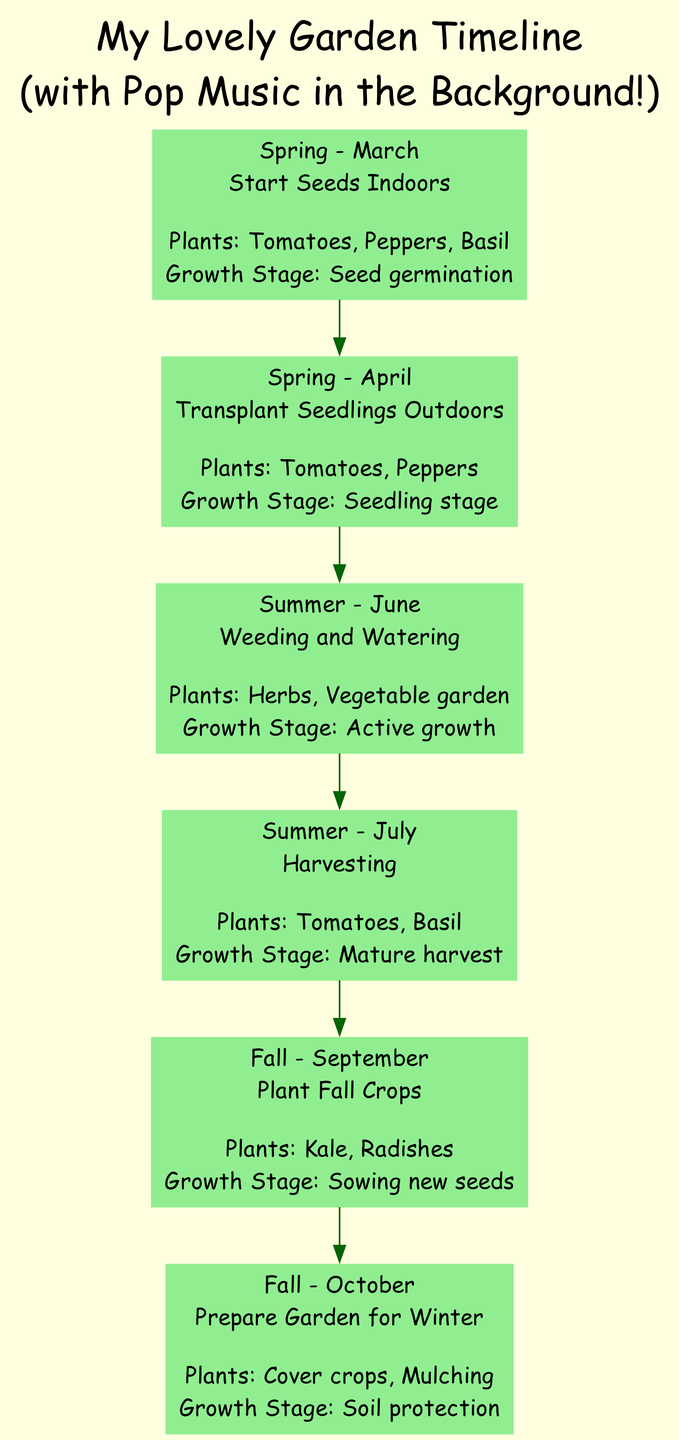What is the first project listed in the timeline? The first project is found at the beginning of the directed graph, which represents the Spring season in March. It describes the project "Start Seeds Indoors" for the plants listed.
Answer: Start Seeds Indoors How many plants are mentioned for the project in July? To find the number of plants mentioned, we look at the July project "Harvesting". The plants listed are "Tomatoes" and "Basil". Counting these gives us a total.
Answer: 2 What growth stage is associated with the "Plant Fall Crops" project? The growth stage is indicated in the same node as the project "Plant Fall Crops" for the month of September, and it notes "Sowing new seeds" in the description.
Answer: Sowing new seeds Which season includes the project for weeding and watering? The project "Weeding and Watering" is placed in the timeline and corresponds to the Summer season outlined in June. By locating this project, we can identify the season it belongs to.
Answer: Summer What are the two plants involved in the October project? In the October project "Prepare Garden for Winter", we can find the relevant plants "Cover crops" and "Mulching" indicated in the node, providing a clear answer.
Answer: Cover crops, Mulching Which month follows the project for transplanting seedlings outdoors? The timeline shows the project "Transplant Seedlings Outdoors" is in April, followed by the next project "Weeding and Watering" in June. Therefore, we look for the month that follows April in the sequence.
Answer: June How many total projects are listed in the timeline? To get the total number of projects, we count each unique project entry in the timeline. There are six distinct project entries throughout the seasons.
Answer: 6 What is the last growth stage mentioned in the timeline? The last project in the timeline occurs in October for "Prepare Garden for Winter". The growth stage is detailed in the project description, noting "Soil protection". By identifying this, we find the last growth stage.
Answer: Soil protection 